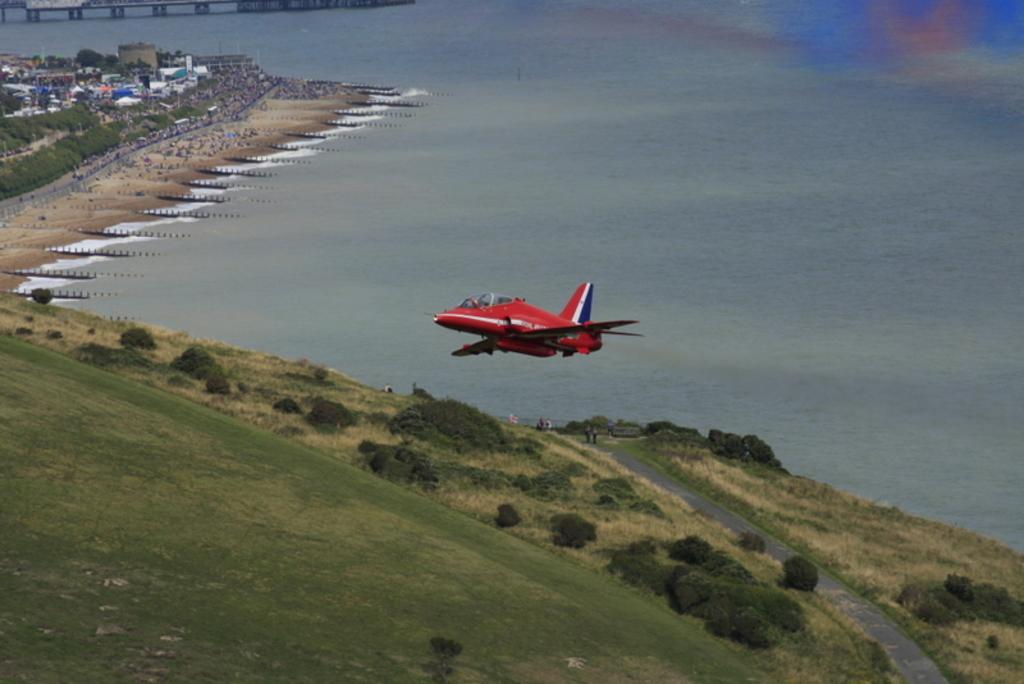Can you describe this image briefly? In the center of the image we can see an airplane flying in the sky. In the background, we can see a group of trees, building, water and a bridge. 